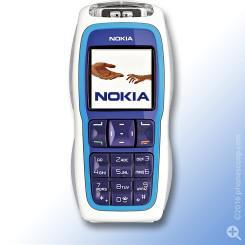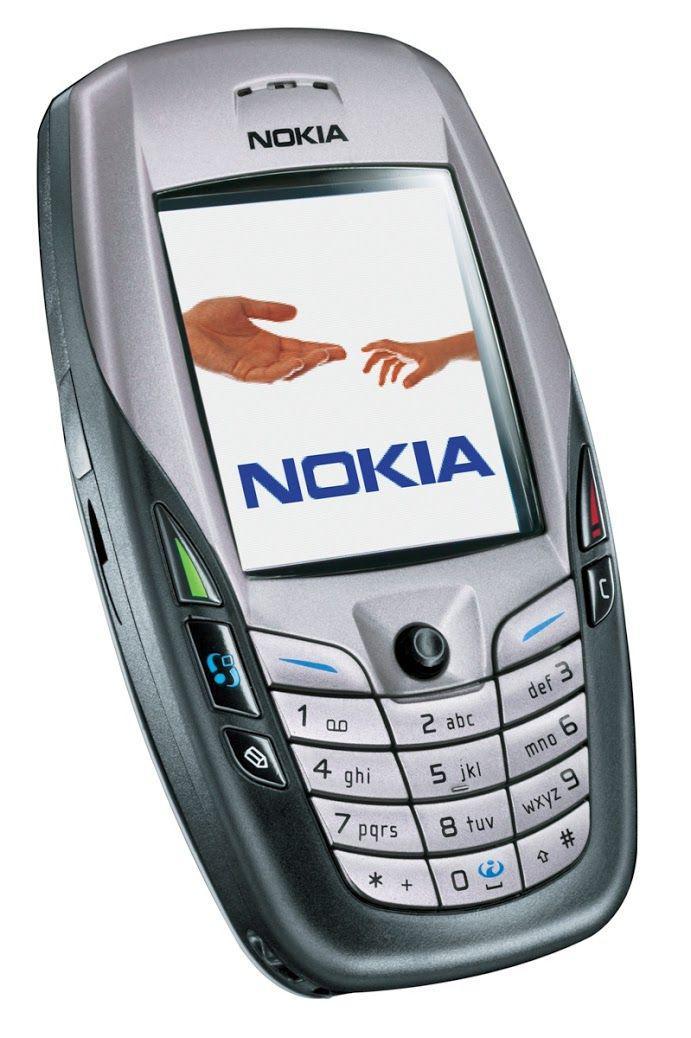The first image is the image on the left, the second image is the image on the right. Analyze the images presented: Is the assertion "The right image contains a single phone displayed upright, and the left image shows one phone overlapping another one that is not in side-view." valid? Answer yes or no. No. 